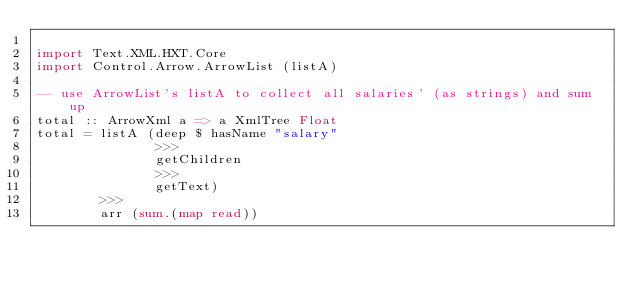<code> <loc_0><loc_0><loc_500><loc_500><_Haskell_> 
import Text.XML.HXT.Core
import Control.Arrow.ArrowList (listA)

-- use ArrowList's listA to collect all salaries' (as strings) and sum up
total :: ArrowXml a => a XmlTree Float
total = listA (deep $ hasName "salary"
               >>> 
               getChildren  
               >>> 
               getText)     
        >>>
        arr (sum.(map read)) </code> 